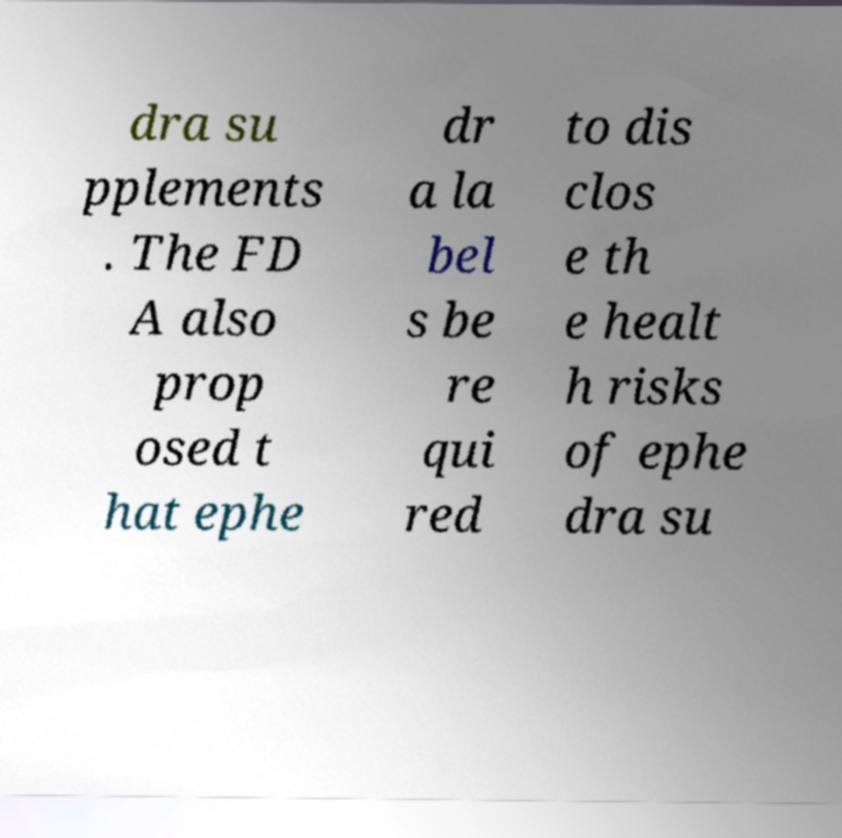Could you extract and type out the text from this image? dra su pplements . The FD A also prop osed t hat ephe dr a la bel s be re qui red to dis clos e th e healt h risks of ephe dra su 